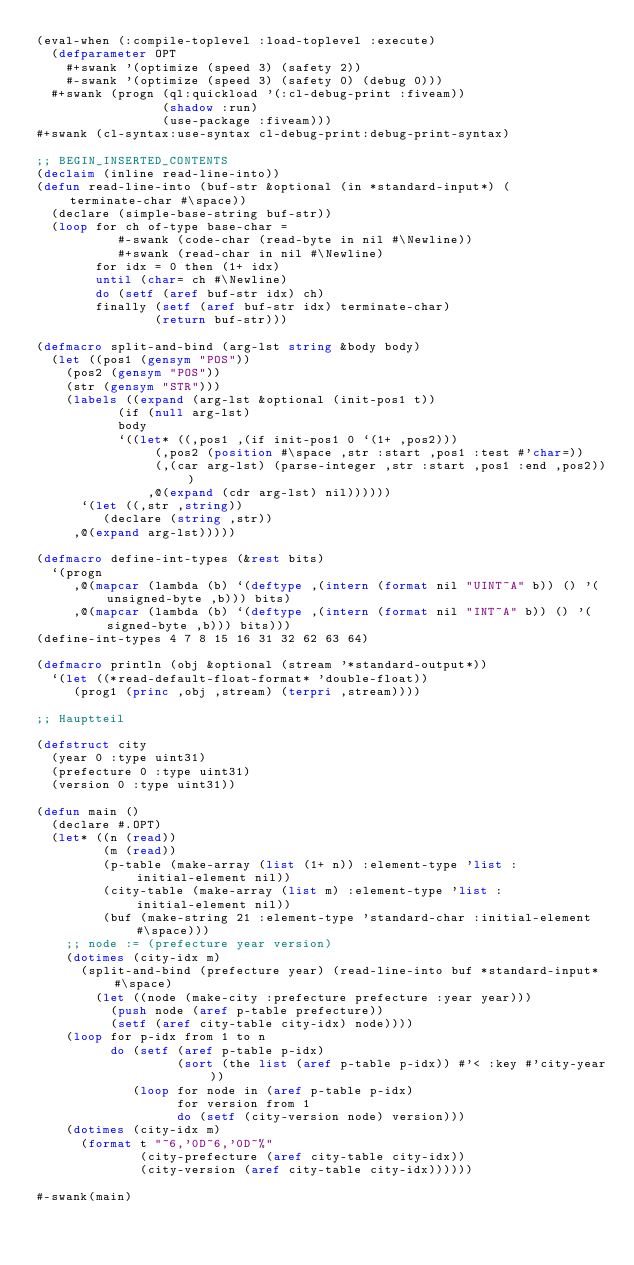Convert code to text. <code><loc_0><loc_0><loc_500><loc_500><_Lisp_>(eval-when (:compile-toplevel :load-toplevel :execute)
  (defparameter OPT
    #+swank '(optimize (speed 3) (safety 2))
    #-swank '(optimize (speed 3) (safety 0) (debug 0)))
  #+swank (progn (ql:quickload '(:cl-debug-print :fiveam))
                 (shadow :run)
                 (use-package :fiveam)))
#+swank (cl-syntax:use-syntax cl-debug-print:debug-print-syntax)

;; BEGIN_INSERTED_CONTENTS
(declaim (inline read-line-into))
(defun read-line-into (buf-str &optional (in *standard-input*) (terminate-char #\space))
  (declare (simple-base-string buf-str))
  (loop for ch of-type base-char =
           #-swank (code-char (read-byte in nil #\Newline))
           #+swank (read-char in nil #\Newline)
        for idx = 0 then (1+ idx)
        until (char= ch #\Newline)
        do (setf (aref buf-str idx) ch)
        finally (setf (aref buf-str idx) terminate-char)
                (return buf-str)))

(defmacro split-and-bind (arg-lst string &body body)
  (let ((pos1 (gensym "POS"))
	(pos2 (gensym "POS"))
	(str (gensym "STR")))
    (labels ((expand (arg-lst &optional (init-pos1 t))
	       (if (null arg-lst)
		   body
		   `((let* ((,pos1 ,(if init-pos1 0 `(1+ ,pos2)))
			    (,pos2 (position #\space ,str :start ,pos1 :test #'char=))
			    (,(car arg-lst) (parse-integer ,str :start ,pos1 :end ,pos2)))
		       ,@(expand (cdr arg-lst) nil))))))
      `(let ((,str ,string))
         (declare (string ,str))
	 ,@(expand arg-lst)))))

(defmacro define-int-types (&rest bits)
  `(progn
     ,@(mapcar (lambda (b) `(deftype ,(intern (format nil "UINT~A" b)) () '(unsigned-byte ,b))) bits)
     ,@(mapcar (lambda (b) `(deftype ,(intern (format nil "INT~A" b)) () '(signed-byte ,b))) bits)))
(define-int-types 4 7 8 15 16 31 32 62 63 64)

(defmacro println (obj &optional (stream '*standard-output*))
  `(let ((*read-default-float-format* 'double-float))
     (prog1 (princ ,obj ,stream) (terpri ,stream))))

;; Hauptteil

(defstruct city
  (year 0 :type uint31)
  (prefecture 0 :type uint31)
  (version 0 :type uint31))

(defun main ()
  (declare #.OPT)
  (let* ((n (read))
         (m (read))
         (p-table (make-array (list (1+ n)) :element-type 'list :initial-element nil))
         (city-table (make-array (list m) :element-type 'list :initial-element nil))
         (buf (make-string 21 :element-type 'standard-char :initial-element #\space)))
    ;; node := (prefecture year version)
    (dotimes (city-idx m)
      (split-and-bind (prefecture year) (read-line-into buf *standard-input* #\space)
        (let ((node (make-city :prefecture prefecture :year year)))
          (push node (aref p-table prefecture))
          (setf (aref city-table city-idx) node))))
    (loop for p-idx from 1 to n
          do (setf (aref p-table p-idx)
                   (sort (the list (aref p-table p-idx)) #'< :key #'city-year))
             (loop for node in (aref p-table p-idx)
                   for version from 1
                   do (setf (city-version node) version)))
    (dotimes (city-idx m)
      (format t "~6,'0D~6,'0D~%"
              (city-prefecture (aref city-table city-idx))
              (city-version (aref city-table city-idx))))))

#-swank(main)
</code> 